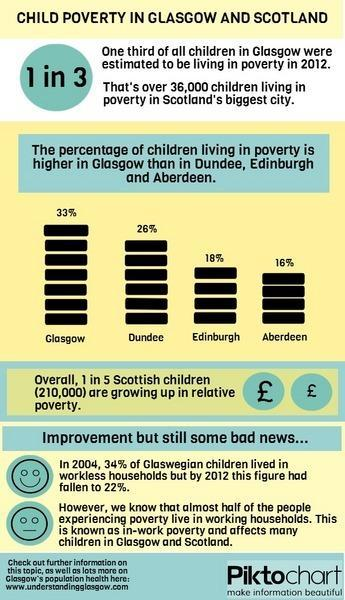By what percent did Glaswegian children living in workless households fall from 2004 to 2012?
Answer the question with a short phrase. 12% After Glasgow, which city has a higher percentage of children living in poverty? Dundee 